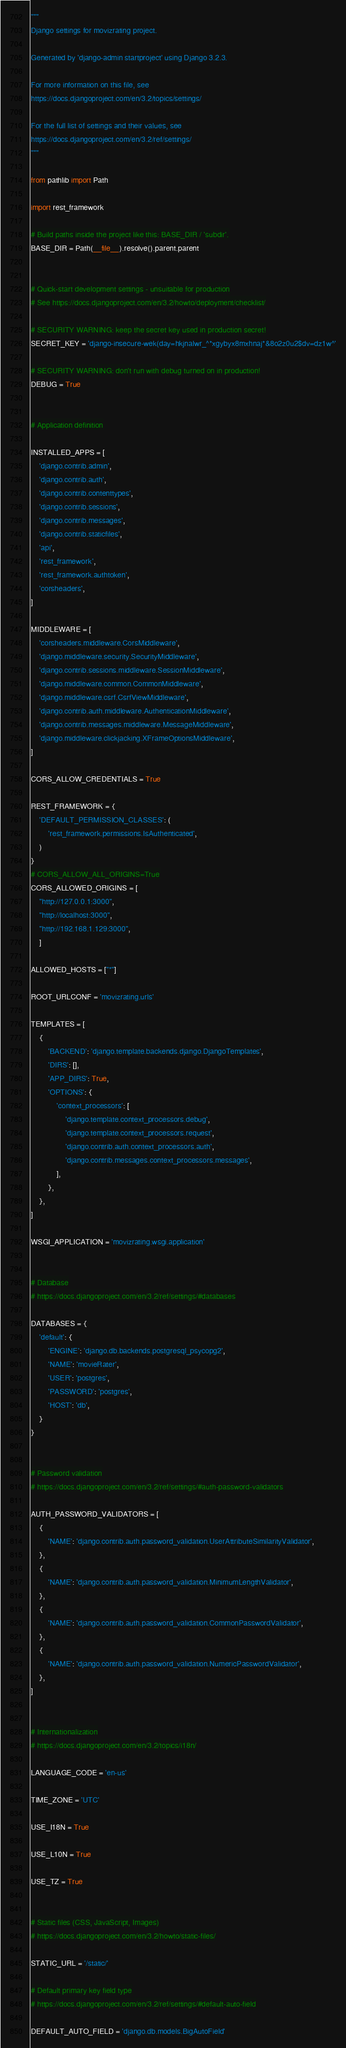Convert code to text. <code><loc_0><loc_0><loc_500><loc_500><_Python_>"""
Django settings for movizrating project.

Generated by 'django-admin startproject' using Django 3.2.3.

For more information on this file, see
https://docs.djangoproject.com/en/3.2/topics/settings/

For the full list of settings and their values, see
https://docs.djangoproject.com/en/3.2/ref/settings/
"""

from pathlib import Path

import rest_framework

# Build paths inside the project like this: BASE_DIR / 'subdir'.
BASE_DIR = Path(__file__).resolve().parent.parent


# Quick-start development settings - unsuitable for production
# See https://docs.djangoproject.com/en/3.2/howto/deployment/checklist/

# SECURITY WARNING: keep the secret key used in production secret!
SECRET_KEY = 'django-insecure-wek(day=hkjnalwr_^*xgybyx8mxhnaj*&8o2z0u2$dv=dz1w^'

# SECURITY WARNING: don't run with debug turned on in production!
DEBUG = True


# Application definition

INSTALLED_APPS = [
    'django.contrib.admin',
    'django.contrib.auth',
    'django.contrib.contenttypes',
    'django.contrib.sessions',
    'django.contrib.messages',
    'django.contrib.staticfiles',
    'api',
    'rest_framework',
    'rest_framework.authtoken',
    'corsheaders',
]

MIDDLEWARE = [
    'corsheaders.middleware.CorsMiddleware',
    'django.middleware.security.SecurityMiddleware',
    'django.contrib.sessions.middleware.SessionMiddleware',
    'django.middleware.common.CommonMiddleware',
    'django.middleware.csrf.CsrfViewMiddleware',
    'django.contrib.auth.middleware.AuthenticationMiddleware',
    'django.contrib.messages.middleware.MessageMiddleware',
    'django.middleware.clickjacking.XFrameOptionsMiddleware',
]

CORS_ALLOW_CREDENTIALS = True

REST_FRAMEWORK = {
    'DEFAULT_PERMISSION_CLASSES': (
        'rest_framework.permissions.IsAuthenticated',
    )
}
# CORS_ALLOW_ALL_ORIGINS=True
CORS_ALLOWED_ORIGINS = [
    "http://127.0.0.1:3000",
    "http://localhost:3000",
    "http://192.168.1.129:3000",
    ]

ALLOWED_HOSTS = ["*"]

ROOT_URLCONF = 'movizrating.urls'

TEMPLATES = [
    {
        'BACKEND': 'django.template.backends.django.DjangoTemplates',
        'DIRS': [],
        'APP_DIRS': True,
        'OPTIONS': {
            'context_processors': [
                'django.template.context_processors.debug',
                'django.template.context_processors.request',
                'django.contrib.auth.context_processors.auth',
                'django.contrib.messages.context_processors.messages',
            ],
        },
    },
]

WSGI_APPLICATION = 'movizrating.wsgi.application'


# Database
# https://docs.djangoproject.com/en/3.2/ref/settings/#databases

DATABASES = {
    'default': {
        'ENGINE': 'django.db.backends.postgresql_psycopg2',
        'NAME': 'movieRater',
        'USER': 'postgres',
        'PASSWORD': 'postgres',
        'HOST': 'db',
    }
}


# Password validation
# https://docs.djangoproject.com/en/3.2/ref/settings/#auth-password-validators

AUTH_PASSWORD_VALIDATORS = [
    {
        'NAME': 'django.contrib.auth.password_validation.UserAttributeSimilarityValidator',
    },
    {
        'NAME': 'django.contrib.auth.password_validation.MinimumLengthValidator',
    },
    {
        'NAME': 'django.contrib.auth.password_validation.CommonPasswordValidator',
    },
    {
        'NAME': 'django.contrib.auth.password_validation.NumericPasswordValidator',
    },
]


# Internationalization
# https://docs.djangoproject.com/en/3.2/topics/i18n/

LANGUAGE_CODE = 'en-us'

TIME_ZONE = 'UTC'

USE_I18N = True

USE_L10N = True

USE_TZ = True


# Static files (CSS, JavaScript, Images)
# https://docs.djangoproject.com/en/3.2/howto/static-files/

STATIC_URL = '/static/'

# Default primary key field type
# https://docs.djangoproject.com/en/3.2/ref/settings/#default-auto-field

DEFAULT_AUTO_FIELD = 'django.db.models.BigAutoField'
</code> 